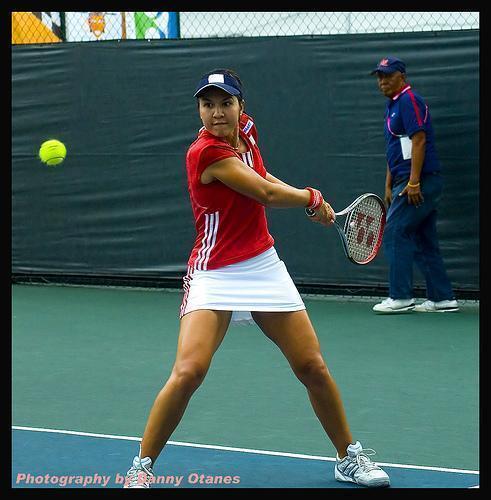The ball used in badminton is made up of what?
Indicate the correct choice and explain in the format: 'Answer: answer
Rationale: rationale.'
Options: Wool, cotton, stone, wood. Answer: wool.
Rationale: Tennis balls have a wool cover on them and a rubber interior. 